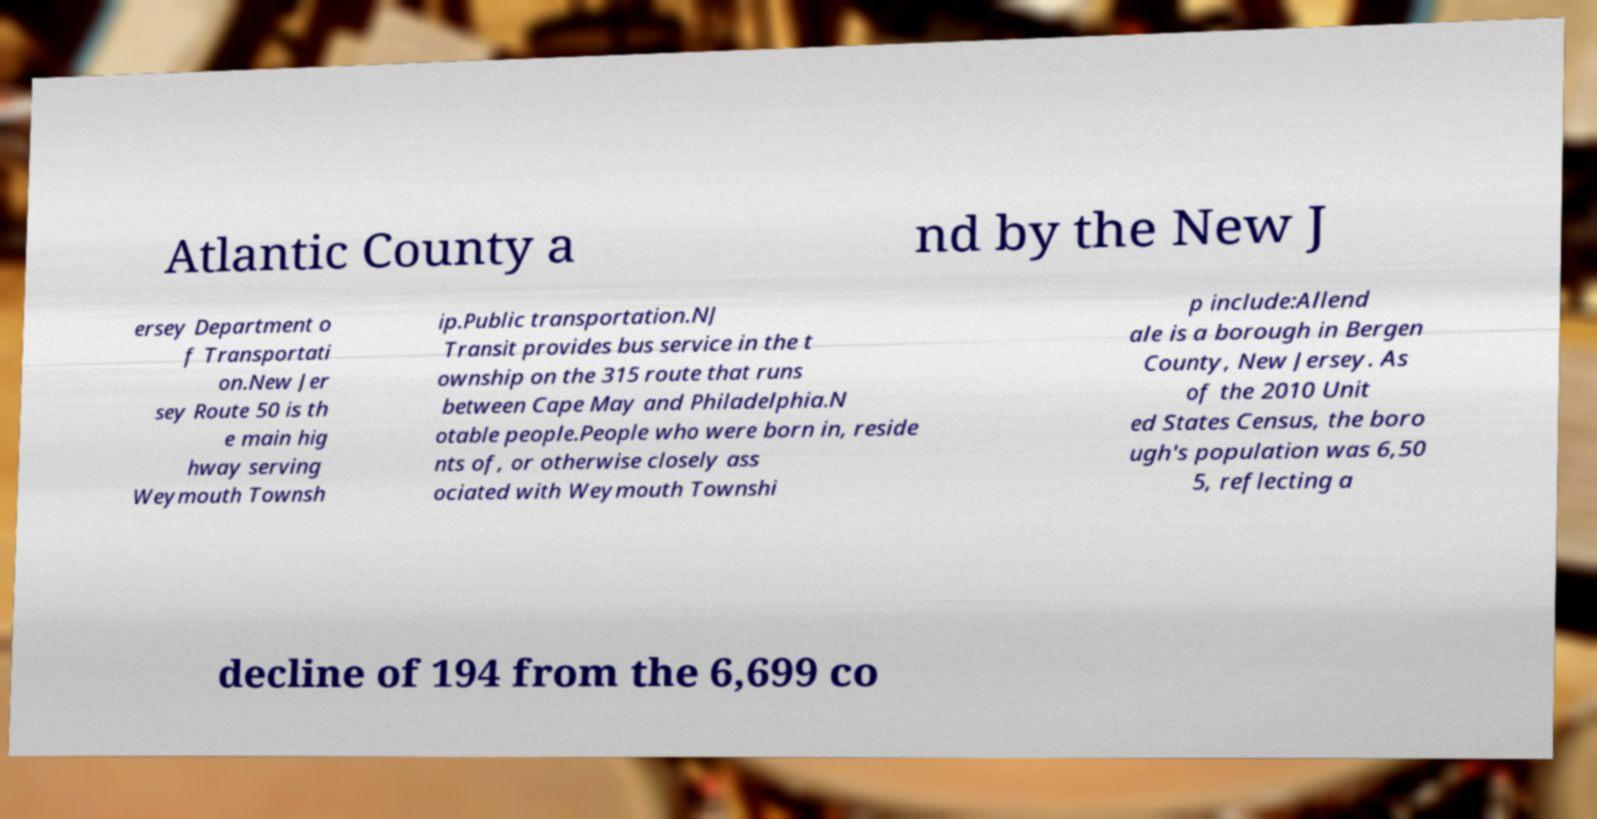Please identify and transcribe the text found in this image. Atlantic County a nd by the New J ersey Department o f Transportati on.New Jer sey Route 50 is th e main hig hway serving Weymouth Townsh ip.Public transportation.NJ Transit provides bus service in the t ownship on the 315 route that runs between Cape May and Philadelphia.N otable people.People who were born in, reside nts of, or otherwise closely ass ociated with Weymouth Townshi p include:Allend ale is a borough in Bergen County, New Jersey. As of the 2010 Unit ed States Census, the boro ugh's population was 6,50 5, reflecting a decline of 194 from the 6,699 co 